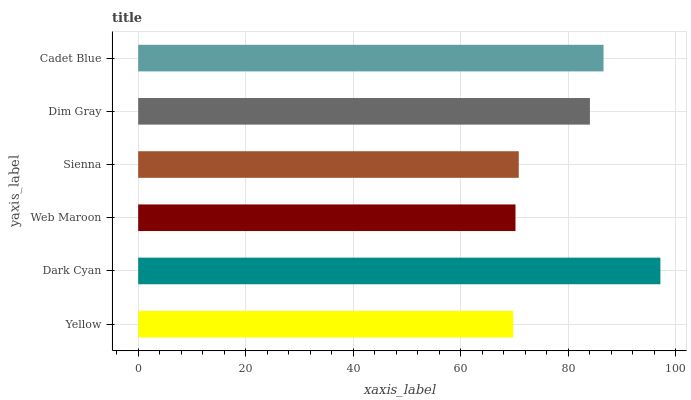Is Yellow the minimum?
Answer yes or no. Yes. Is Dark Cyan the maximum?
Answer yes or no. Yes. Is Web Maroon the minimum?
Answer yes or no. No. Is Web Maroon the maximum?
Answer yes or no. No. Is Dark Cyan greater than Web Maroon?
Answer yes or no. Yes. Is Web Maroon less than Dark Cyan?
Answer yes or no. Yes. Is Web Maroon greater than Dark Cyan?
Answer yes or no. No. Is Dark Cyan less than Web Maroon?
Answer yes or no. No. Is Dim Gray the high median?
Answer yes or no. Yes. Is Sienna the low median?
Answer yes or no. Yes. Is Yellow the high median?
Answer yes or no. No. Is Dark Cyan the low median?
Answer yes or no. No. 